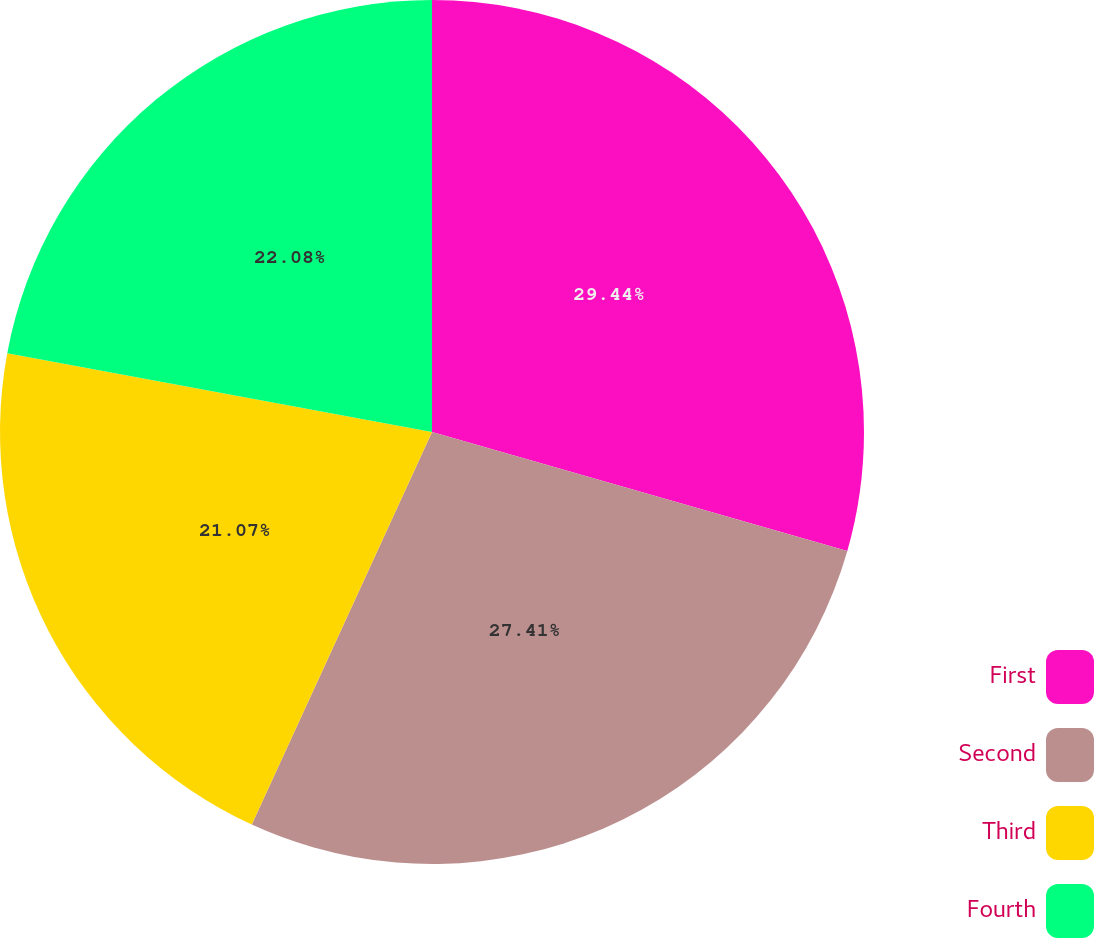<chart> <loc_0><loc_0><loc_500><loc_500><pie_chart><fcel>First<fcel>Second<fcel>Third<fcel>Fourth<nl><fcel>29.44%<fcel>27.41%<fcel>21.07%<fcel>22.08%<nl></chart> 